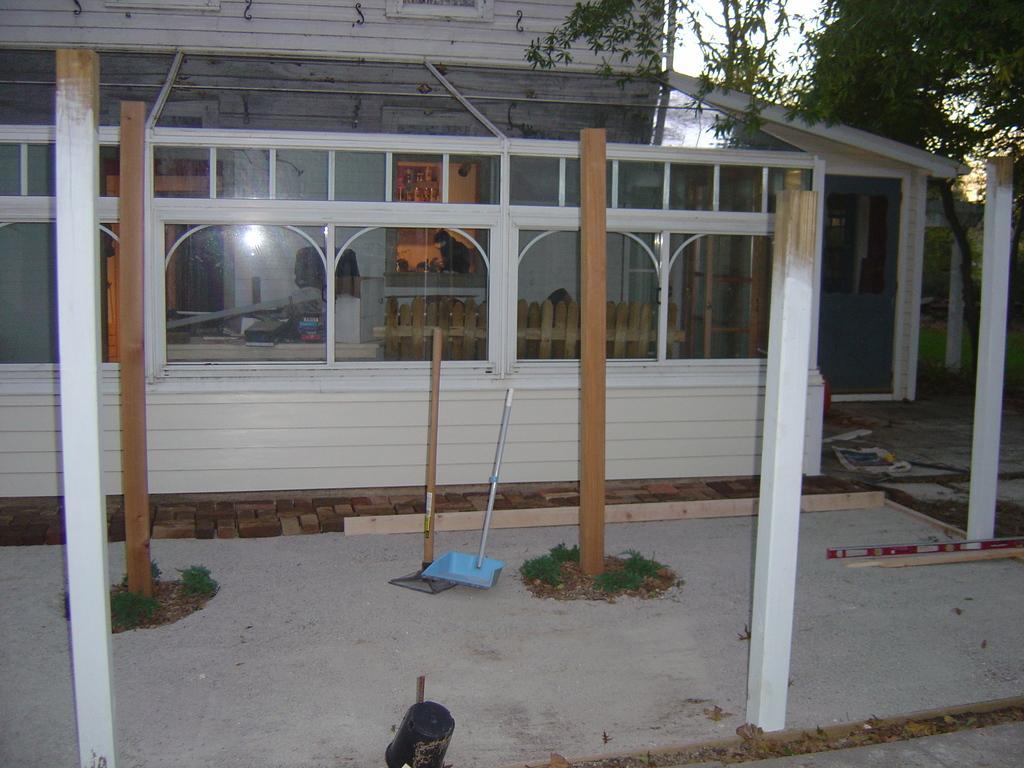In one or two sentences, can you explain what this image depicts? The picture is taken from, outside the house. In the foreground there are poles, grass and some wooden objects. In the center of the picture there is house with glass windows and doors. On the right there are trees. 